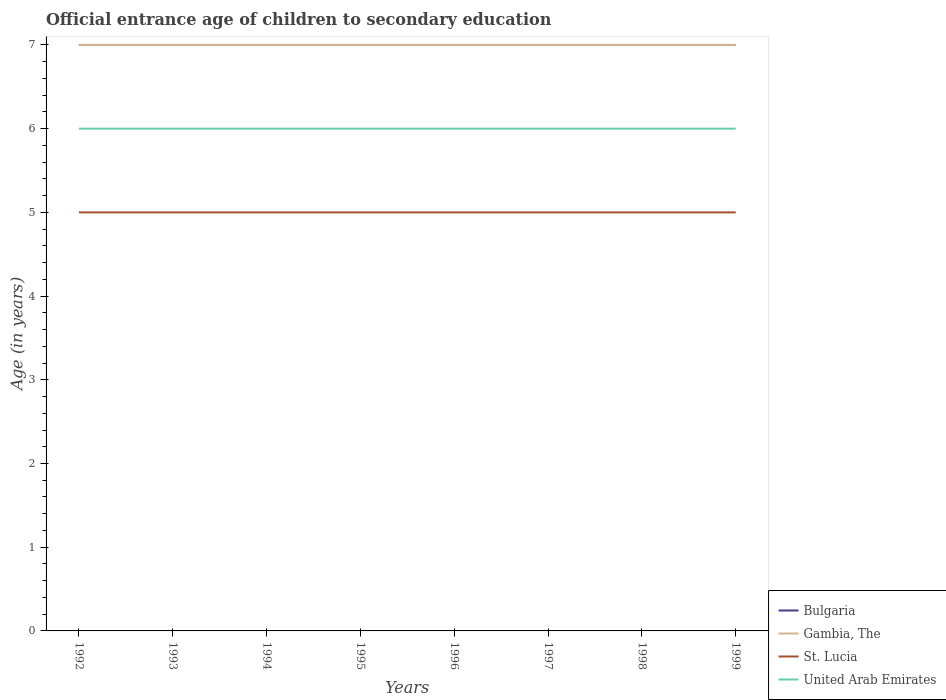Across all years, what is the maximum secondary school starting age of children in Bulgaria?
Ensure brevity in your answer.  7. What is the total secondary school starting age of children in United Arab Emirates in the graph?
Give a very brief answer. 0. What is the difference between the highest and the lowest secondary school starting age of children in United Arab Emirates?
Give a very brief answer. 0. How many lines are there?
Keep it short and to the point. 4. What is the difference between two consecutive major ticks on the Y-axis?
Offer a very short reply. 1. Are the values on the major ticks of Y-axis written in scientific E-notation?
Your answer should be compact. No. How many legend labels are there?
Provide a succinct answer. 4. How are the legend labels stacked?
Ensure brevity in your answer.  Vertical. What is the title of the graph?
Your answer should be compact. Official entrance age of children to secondary education. What is the label or title of the X-axis?
Your answer should be very brief. Years. What is the label or title of the Y-axis?
Offer a very short reply. Age (in years). What is the Age (in years) in Bulgaria in 1993?
Your answer should be very brief. 7. What is the Age (in years) in Gambia, The in 1993?
Your answer should be compact. 7. What is the Age (in years) of United Arab Emirates in 1993?
Offer a terse response. 6. What is the Age (in years) in Bulgaria in 1994?
Give a very brief answer. 7. What is the Age (in years) of Gambia, The in 1994?
Give a very brief answer. 7. What is the Age (in years) in United Arab Emirates in 1994?
Offer a terse response. 6. What is the Age (in years) in Gambia, The in 1995?
Offer a terse response. 7. What is the Age (in years) of St. Lucia in 1995?
Make the answer very short. 5. What is the Age (in years) in United Arab Emirates in 1995?
Provide a succinct answer. 6. What is the Age (in years) of Bulgaria in 1996?
Keep it short and to the point. 7. What is the Age (in years) of St. Lucia in 1996?
Give a very brief answer. 5. What is the Age (in years) in Gambia, The in 1997?
Offer a very short reply. 7. What is the Age (in years) of Bulgaria in 1998?
Keep it short and to the point. 7. What is the Age (in years) of Gambia, The in 1998?
Make the answer very short. 7. What is the Age (in years) of United Arab Emirates in 1998?
Ensure brevity in your answer.  6. What is the Age (in years) of St. Lucia in 1999?
Make the answer very short. 5. Across all years, what is the maximum Age (in years) in Gambia, The?
Your response must be concise. 7. Across all years, what is the maximum Age (in years) of United Arab Emirates?
Your response must be concise. 6. Across all years, what is the minimum Age (in years) of Bulgaria?
Keep it short and to the point. 7. Across all years, what is the minimum Age (in years) in Gambia, The?
Provide a succinct answer. 7. Across all years, what is the minimum Age (in years) of United Arab Emirates?
Your answer should be compact. 6. What is the total Age (in years) of St. Lucia in the graph?
Ensure brevity in your answer.  40. What is the difference between the Age (in years) in Bulgaria in 1992 and that in 1993?
Make the answer very short. 0. What is the difference between the Age (in years) in St. Lucia in 1992 and that in 1993?
Your answer should be very brief. 0. What is the difference between the Age (in years) of Bulgaria in 1992 and that in 1994?
Offer a very short reply. 0. What is the difference between the Age (in years) of Gambia, The in 1992 and that in 1994?
Your response must be concise. 0. What is the difference between the Age (in years) in St. Lucia in 1992 and that in 1994?
Your answer should be compact. 0. What is the difference between the Age (in years) in Bulgaria in 1992 and that in 1995?
Offer a terse response. 0. What is the difference between the Age (in years) of Gambia, The in 1992 and that in 1995?
Your answer should be very brief. 0. What is the difference between the Age (in years) in United Arab Emirates in 1992 and that in 1996?
Offer a very short reply. 0. What is the difference between the Age (in years) in Gambia, The in 1992 and that in 1997?
Provide a succinct answer. 0. What is the difference between the Age (in years) of St. Lucia in 1992 and that in 1997?
Offer a terse response. 0. What is the difference between the Age (in years) of United Arab Emirates in 1992 and that in 1997?
Ensure brevity in your answer.  0. What is the difference between the Age (in years) of Bulgaria in 1992 and that in 1998?
Make the answer very short. 0. What is the difference between the Age (in years) of Gambia, The in 1992 and that in 1998?
Your answer should be compact. 0. What is the difference between the Age (in years) of St. Lucia in 1992 and that in 1998?
Ensure brevity in your answer.  0. What is the difference between the Age (in years) of United Arab Emirates in 1992 and that in 1998?
Give a very brief answer. 0. What is the difference between the Age (in years) of Bulgaria in 1992 and that in 1999?
Your answer should be very brief. 0. What is the difference between the Age (in years) of Gambia, The in 1992 and that in 1999?
Make the answer very short. 0. What is the difference between the Age (in years) in St. Lucia in 1992 and that in 1999?
Offer a terse response. 0. What is the difference between the Age (in years) in Bulgaria in 1993 and that in 1994?
Provide a short and direct response. 0. What is the difference between the Age (in years) of St. Lucia in 1993 and that in 1994?
Give a very brief answer. 0. What is the difference between the Age (in years) of St. Lucia in 1993 and that in 1995?
Provide a succinct answer. 0. What is the difference between the Age (in years) of United Arab Emirates in 1993 and that in 1995?
Keep it short and to the point. 0. What is the difference between the Age (in years) of Bulgaria in 1993 and that in 1996?
Provide a succinct answer. 0. What is the difference between the Age (in years) of Gambia, The in 1993 and that in 1996?
Your response must be concise. 0. What is the difference between the Age (in years) of St. Lucia in 1993 and that in 1996?
Give a very brief answer. 0. What is the difference between the Age (in years) in Bulgaria in 1993 and that in 1997?
Provide a succinct answer. 0. What is the difference between the Age (in years) of Gambia, The in 1993 and that in 1997?
Give a very brief answer. 0. What is the difference between the Age (in years) of Gambia, The in 1993 and that in 1998?
Offer a very short reply. 0. What is the difference between the Age (in years) of St. Lucia in 1993 and that in 1998?
Provide a short and direct response. 0. What is the difference between the Age (in years) of Bulgaria in 1993 and that in 1999?
Provide a short and direct response. 0. What is the difference between the Age (in years) in Gambia, The in 1993 and that in 1999?
Ensure brevity in your answer.  0. What is the difference between the Age (in years) in St. Lucia in 1993 and that in 1999?
Give a very brief answer. 0. What is the difference between the Age (in years) of United Arab Emirates in 1993 and that in 1999?
Provide a short and direct response. 0. What is the difference between the Age (in years) of Bulgaria in 1994 and that in 1995?
Offer a very short reply. 0. What is the difference between the Age (in years) in St. Lucia in 1994 and that in 1995?
Provide a short and direct response. 0. What is the difference between the Age (in years) in Bulgaria in 1994 and that in 1996?
Your answer should be very brief. 0. What is the difference between the Age (in years) in Gambia, The in 1994 and that in 1996?
Ensure brevity in your answer.  0. What is the difference between the Age (in years) in Bulgaria in 1994 and that in 1997?
Provide a succinct answer. 0. What is the difference between the Age (in years) of Gambia, The in 1994 and that in 1997?
Make the answer very short. 0. What is the difference between the Age (in years) of St. Lucia in 1994 and that in 1997?
Provide a short and direct response. 0. What is the difference between the Age (in years) of Gambia, The in 1994 and that in 1998?
Offer a terse response. 0. What is the difference between the Age (in years) of St. Lucia in 1994 and that in 1998?
Make the answer very short. 0. What is the difference between the Age (in years) in United Arab Emirates in 1994 and that in 1998?
Your answer should be very brief. 0. What is the difference between the Age (in years) of Gambia, The in 1994 and that in 1999?
Provide a succinct answer. 0. What is the difference between the Age (in years) in St. Lucia in 1994 and that in 1999?
Keep it short and to the point. 0. What is the difference between the Age (in years) of United Arab Emirates in 1994 and that in 1999?
Offer a very short reply. 0. What is the difference between the Age (in years) in Bulgaria in 1995 and that in 1996?
Make the answer very short. 0. What is the difference between the Age (in years) of Bulgaria in 1995 and that in 1997?
Provide a succinct answer. 0. What is the difference between the Age (in years) of Gambia, The in 1995 and that in 1997?
Your answer should be very brief. 0. What is the difference between the Age (in years) of United Arab Emirates in 1995 and that in 1997?
Make the answer very short. 0. What is the difference between the Age (in years) in Bulgaria in 1995 and that in 1998?
Offer a terse response. 0. What is the difference between the Age (in years) in Gambia, The in 1995 and that in 1998?
Give a very brief answer. 0. What is the difference between the Age (in years) in United Arab Emirates in 1995 and that in 1998?
Provide a short and direct response. 0. What is the difference between the Age (in years) of Bulgaria in 1995 and that in 1999?
Offer a terse response. 0. What is the difference between the Age (in years) in United Arab Emirates in 1995 and that in 1999?
Your answer should be compact. 0. What is the difference between the Age (in years) in Bulgaria in 1996 and that in 1997?
Your answer should be very brief. 0. What is the difference between the Age (in years) in St. Lucia in 1996 and that in 1997?
Your response must be concise. 0. What is the difference between the Age (in years) in United Arab Emirates in 1996 and that in 1997?
Provide a succinct answer. 0. What is the difference between the Age (in years) in Gambia, The in 1996 and that in 1998?
Provide a short and direct response. 0. What is the difference between the Age (in years) in St. Lucia in 1996 and that in 1998?
Offer a terse response. 0. What is the difference between the Age (in years) of Gambia, The in 1996 and that in 1999?
Your answer should be very brief. 0. What is the difference between the Age (in years) in St. Lucia in 1996 and that in 1999?
Ensure brevity in your answer.  0. What is the difference between the Age (in years) in United Arab Emirates in 1996 and that in 1999?
Keep it short and to the point. 0. What is the difference between the Age (in years) in Bulgaria in 1997 and that in 1998?
Give a very brief answer. 0. What is the difference between the Age (in years) of St. Lucia in 1997 and that in 1998?
Your answer should be compact. 0. What is the difference between the Age (in years) of St. Lucia in 1997 and that in 1999?
Your answer should be compact. 0. What is the difference between the Age (in years) in United Arab Emirates in 1997 and that in 1999?
Provide a short and direct response. 0. What is the difference between the Age (in years) of Gambia, The in 1998 and that in 1999?
Your answer should be very brief. 0. What is the difference between the Age (in years) in Bulgaria in 1992 and the Age (in years) in Gambia, The in 1993?
Your answer should be compact. 0. What is the difference between the Age (in years) of Bulgaria in 1992 and the Age (in years) of United Arab Emirates in 1993?
Your answer should be very brief. 1. What is the difference between the Age (in years) of Gambia, The in 1992 and the Age (in years) of United Arab Emirates in 1993?
Give a very brief answer. 1. What is the difference between the Age (in years) of St. Lucia in 1992 and the Age (in years) of United Arab Emirates in 1993?
Make the answer very short. -1. What is the difference between the Age (in years) of Bulgaria in 1992 and the Age (in years) of United Arab Emirates in 1994?
Provide a succinct answer. 1. What is the difference between the Age (in years) in Gambia, The in 1992 and the Age (in years) in United Arab Emirates in 1995?
Offer a very short reply. 1. What is the difference between the Age (in years) in Bulgaria in 1992 and the Age (in years) in Gambia, The in 1996?
Give a very brief answer. 0. What is the difference between the Age (in years) in Bulgaria in 1992 and the Age (in years) in St. Lucia in 1996?
Ensure brevity in your answer.  2. What is the difference between the Age (in years) in Bulgaria in 1992 and the Age (in years) in United Arab Emirates in 1996?
Provide a short and direct response. 1. What is the difference between the Age (in years) of Gambia, The in 1992 and the Age (in years) of St. Lucia in 1996?
Keep it short and to the point. 2. What is the difference between the Age (in years) of Gambia, The in 1992 and the Age (in years) of United Arab Emirates in 1996?
Provide a succinct answer. 1. What is the difference between the Age (in years) of St. Lucia in 1992 and the Age (in years) of United Arab Emirates in 1996?
Keep it short and to the point. -1. What is the difference between the Age (in years) in Bulgaria in 1992 and the Age (in years) in St. Lucia in 1997?
Make the answer very short. 2. What is the difference between the Age (in years) in Bulgaria in 1992 and the Age (in years) in United Arab Emirates in 1997?
Offer a terse response. 1. What is the difference between the Age (in years) of St. Lucia in 1992 and the Age (in years) of United Arab Emirates in 1997?
Provide a short and direct response. -1. What is the difference between the Age (in years) of Bulgaria in 1992 and the Age (in years) of Gambia, The in 1998?
Offer a terse response. 0. What is the difference between the Age (in years) of Bulgaria in 1992 and the Age (in years) of St. Lucia in 1998?
Give a very brief answer. 2. What is the difference between the Age (in years) in Bulgaria in 1992 and the Age (in years) in United Arab Emirates in 1998?
Offer a terse response. 1. What is the difference between the Age (in years) of Gambia, The in 1992 and the Age (in years) of St. Lucia in 1998?
Offer a terse response. 2. What is the difference between the Age (in years) of Gambia, The in 1992 and the Age (in years) of United Arab Emirates in 1998?
Give a very brief answer. 1. What is the difference between the Age (in years) in Bulgaria in 1992 and the Age (in years) in St. Lucia in 1999?
Offer a very short reply. 2. What is the difference between the Age (in years) in Bulgaria in 1992 and the Age (in years) in United Arab Emirates in 1999?
Offer a terse response. 1. What is the difference between the Age (in years) of Bulgaria in 1993 and the Age (in years) of Gambia, The in 1994?
Provide a short and direct response. 0. What is the difference between the Age (in years) of Bulgaria in 1993 and the Age (in years) of United Arab Emirates in 1994?
Provide a succinct answer. 1. What is the difference between the Age (in years) of Gambia, The in 1993 and the Age (in years) of United Arab Emirates in 1994?
Offer a very short reply. 1. What is the difference between the Age (in years) of St. Lucia in 1993 and the Age (in years) of United Arab Emirates in 1994?
Ensure brevity in your answer.  -1. What is the difference between the Age (in years) of Bulgaria in 1993 and the Age (in years) of St. Lucia in 1995?
Your answer should be very brief. 2. What is the difference between the Age (in years) of Bulgaria in 1993 and the Age (in years) of United Arab Emirates in 1995?
Keep it short and to the point. 1. What is the difference between the Age (in years) of Gambia, The in 1993 and the Age (in years) of St. Lucia in 1995?
Ensure brevity in your answer.  2. What is the difference between the Age (in years) of Bulgaria in 1993 and the Age (in years) of Gambia, The in 1996?
Provide a short and direct response. 0. What is the difference between the Age (in years) in Bulgaria in 1993 and the Age (in years) in St. Lucia in 1996?
Ensure brevity in your answer.  2. What is the difference between the Age (in years) of Bulgaria in 1993 and the Age (in years) of United Arab Emirates in 1996?
Your answer should be very brief. 1. What is the difference between the Age (in years) in St. Lucia in 1993 and the Age (in years) in United Arab Emirates in 1996?
Keep it short and to the point. -1. What is the difference between the Age (in years) in Bulgaria in 1993 and the Age (in years) in St. Lucia in 1997?
Provide a succinct answer. 2. What is the difference between the Age (in years) of Gambia, The in 1993 and the Age (in years) of St. Lucia in 1997?
Your answer should be compact. 2. What is the difference between the Age (in years) of Gambia, The in 1993 and the Age (in years) of St. Lucia in 1998?
Give a very brief answer. 2. What is the difference between the Age (in years) of Gambia, The in 1993 and the Age (in years) of United Arab Emirates in 1998?
Offer a terse response. 1. What is the difference between the Age (in years) of St. Lucia in 1993 and the Age (in years) of United Arab Emirates in 1998?
Give a very brief answer. -1. What is the difference between the Age (in years) of Bulgaria in 1993 and the Age (in years) of Gambia, The in 1999?
Provide a succinct answer. 0. What is the difference between the Age (in years) in Bulgaria in 1993 and the Age (in years) in St. Lucia in 1999?
Ensure brevity in your answer.  2. What is the difference between the Age (in years) in Gambia, The in 1993 and the Age (in years) in United Arab Emirates in 1999?
Make the answer very short. 1. What is the difference between the Age (in years) of St. Lucia in 1993 and the Age (in years) of United Arab Emirates in 1999?
Keep it short and to the point. -1. What is the difference between the Age (in years) in Bulgaria in 1994 and the Age (in years) in Gambia, The in 1995?
Give a very brief answer. 0. What is the difference between the Age (in years) in Bulgaria in 1994 and the Age (in years) in St. Lucia in 1995?
Offer a terse response. 2. What is the difference between the Age (in years) in St. Lucia in 1994 and the Age (in years) in United Arab Emirates in 1995?
Keep it short and to the point. -1. What is the difference between the Age (in years) in Bulgaria in 1994 and the Age (in years) in Gambia, The in 1996?
Your answer should be compact. 0. What is the difference between the Age (in years) in Bulgaria in 1994 and the Age (in years) in St. Lucia in 1996?
Offer a terse response. 2. What is the difference between the Age (in years) of Bulgaria in 1994 and the Age (in years) of United Arab Emirates in 1996?
Offer a terse response. 1. What is the difference between the Age (in years) of Gambia, The in 1994 and the Age (in years) of St. Lucia in 1996?
Provide a succinct answer. 2. What is the difference between the Age (in years) of St. Lucia in 1994 and the Age (in years) of United Arab Emirates in 1996?
Provide a succinct answer. -1. What is the difference between the Age (in years) of Bulgaria in 1994 and the Age (in years) of Gambia, The in 1997?
Offer a terse response. 0. What is the difference between the Age (in years) in Bulgaria in 1994 and the Age (in years) in St. Lucia in 1997?
Offer a very short reply. 2. What is the difference between the Age (in years) in Bulgaria in 1994 and the Age (in years) in United Arab Emirates in 1998?
Give a very brief answer. 1. What is the difference between the Age (in years) in Gambia, The in 1994 and the Age (in years) in St. Lucia in 1998?
Provide a short and direct response. 2. What is the difference between the Age (in years) in Gambia, The in 1994 and the Age (in years) in United Arab Emirates in 1998?
Your answer should be compact. 1. What is the difference between the Age (in years) in St. Lucia in 1994 and the Age (in years) in United Arab Emirates in 1998?
Your answer should be very brief. -1. What is the difference between the Age (in years) of Gambia, The in 1994 and the Age (in years) of St. Lucia in 1999?
Keep it short and to the point. 2. What is the difference between the Age (in years) of Bulgaria in 1995 and the Age (in years) of St. Lucia in 1996?
Provide a succinct answer. 2. What is the difference between the Age (in years) in St. Lucia in 1995 and the Age (in years) in United Arab Emirates in 1997?
Provide a short and direct response. -1. What is the difference between the Age (in years) in Bulgaria in 1995 and the Age (in years) in St. Lucia in 1998?
Offer a terse response. 2. What is the difference between the Age (in years) of Gambia, The in 1995 and the Age (in years) of United Arab Emirates in 1998?
Provide a succinct answer. 1. What is the difference between the Age (in years) in St. Lucia in 1995 and the Age (in years) in United Arab Emirates in 1998?
Give a very brief answer. -1. What is the difference between the Age (in years) in Bulgaria in 1995 and the Age (in years) in United Arab Emirates in 1999?
Make the answer very short. 1. What is the difference between the Age (in years) in Gambia, The in 1995 and the Age (in years) in St. Lucia in 1999?
Provide a succinct answer. 2. What is the difference between the Age (in years) in Bulgaria in 1996 and the Age (in years) in Gambia, The in 1997?
Offer a terse response. 0. What is the difference between the Age (in years) in Bulgaria in 1996 and the Age (in years) in United Arab Emirates in 1997?
Provide a succinct answer. 1. What is the difference between the Age (in years) in Gambia, The in 1996 and the Age (in years) in St. Lucia in 1997?
Keep it short and to the point. 2. What is the difference between the Age (in years) of Gambia, The in 1996 and the Age (in years) of St. Lucia in 1998?
Ensure brevity in your answer.  2. What is the difference between the Age (in years) of Gambia, The in 1996 and the Age (in years) of United Arab Emirates in 1998?
Offer a terse response. 1. What is the difference between the Age (in years) of St. Lucia in 1996 and the Age (in years) of United Arab Emirates in 1998?
Make the answer very short. -1. What is the difference between the Age (in years) of Bulgaria in 1996 and the Age (in years) of Gambia, The in 1999?
Ensure brevity in your answer.  0. What is the difference between the Age (in years) of Bulgaria in 1997 and the Age (in years) of Gambia, The in 1998?
Offer a terse response. 0. What is the difference between the Age (in years) in Bulgaria in 1997 and the Age (in years) in St. Lucia in 1998?
Your answer should be very brief. 2. What is the difference between the Age (in years) in St. Lucia in 1997 and the Age (in years) in United Arab Emirates in 1999?
Ensure brevity in your answer.  -1. What is the difference between the Age (in years) of Bulgaria in 1998 and the Age (in years) of Gambia, The in 1999?
Offer a very short reply. 0. What is the difference between the Age (in years) in St. Lucia in 1998 and the Age (in years) in United Arab Emirates in 1999?
Offer a terse response. -1. What is the average Age (in years) in United Arab Emirates per year?
Provide a short and direct response. 6. In the year 1992, what is the difference between the Age (in years) in Bulgaria and Age (in years) in Gambia, The?
Provide a succinct answer. 0. In the year 1992, what is the difference between the Age (in years) of Bulgaria and Age (in years) of St. Lucia?
Make the answer very short. 2. In the year 1992, what is the difference between the Age (in years) in Gambia, The and Age (in years) in St. Lucia?
Make the answer very short. 2. In the year 1992, what is the difference between the Age (in years) of St. Lucia and Age (in years) of United Arab Emirates?
Make the answer very short. -1. In the year 1993, what is the difference between the Age (in years) of Bulgaria and Age (in years) of St. Lucia?
Provide a succinct answer. 2. In the year 1993, what is the difference between the Age (in years) in Gambia, The and Age (in years) in United Arab Emirates?
Your answer should be compact. 1. In the year 1993, what is the difference between the Age (in years) in St. Lucia and Age (in years) in United Arab Emirates?
Provide a succinct answer. -1. In the year 1994, what is the difference between the Age (in years) in Bulgaria and Age (in years) in Gambia, The?
Your response must be concise. 0. In the year 1994, what is the difference between the Age (in years) of Bulgaria and Age (in years) of United Arab Emirates?
Your answer should be compact. 1. In the year 1994, what is the difference between the Age (in years) of Gambia, The and Age (in years) of United Arab Emirates?
Offer a terse response. 1. In the year 1995, what is the difference between the Age (in years) in Bulgaria and Age (in years) in Gambia, The?
Give a very brief answer. 0. In the year 1995, what is the difference between the Age (in years) in Bulgaria and Age (in years) in St. Lucia?
Offer a very short reply. 2. In the year 1995, what is the difference between the Age (in years) in Bulgaria and Age (in years) in United Arab Emirates?
Make the answer very short. 1. In the year 1995, what is the difference between the Age (in years) in Gambia, The and Age (in years) in St. Lucia?
Make the answer very short. 2. In the year 1995, what is the difference between the Age (in years) of St. Lucia and Age (in years) of United Arab Emirates?
Make the answer very short. -1. In the year 1996, what is the difference between the Age (in years) in Bulgaria and Age (in years) in Gambia, The?
Keep it short and to the point. 0. In the year 1996, what is the difference between the Age (in years) of Bulgaria and Age (in years) of United Arab Emirates?
Offer a terse response. 1. In the year 1996, what is the difference between the Age (in years) of Gambia, The and Age (in years) of St. Lucia?
Your answer should be compact. 2. In the year 1996, what is the difference between the Age (in years) of Gambia, The and Age (in years) of United Arab Emirates?
Ensure brevity in your answer.  1. In the year 1997, what is the difference between the Age (in years) of Bulgaria and Age (in years) of Gambia, The?
Your response must be concise. 0. In the year 1997, what is the difference between the Age (in years) in Bulgaria and Age (in years) in St. Lucia?
Offer a very short reply. 2. In the year 1997, what is the difference between the Age (in years) in Gambia, The and Age (in years) in United Arab Emirates?
Your answer should be very brief. 1. In the year 1998, what is the difference between the Age (in years) in Bulgaria and Age (in years) in Gambia, The?
Offer a very short reply. 0. In the year 1998, what is the difference between the Age (in years) of Bulgaria and Age (in years) of St. Lucia?
Provide a succinct answer. 2. In the year 1998, what is the difference between the Age (in years) in Gambia, The and Age (in years) in St. Lucia?
Offer a very short reply. 2. In the year 1998, what is the difference between the Age (in years) of St. Lucia and Age (in years) of United Arab Emirates?
Offer a very short reply. -1. In the year 1999, what is the difference between the Age (in years) in Bulgaria and Age (in years) in Gambia, The?
Provide a short and direct response. 0. In the year 1999, what is the difference between the Age (in years) of Gambia, The and Age (in years) of St. Lucia?
Give a very brief answer. 2. In the year 1999, what is the difference between the Age (in years) in St. Lucia and Age (in years) in United Arab Emirates?
Your response must be concise. -1. What is the ratio of the Age (in years) of Bulgaria in 1992 to that in 1993?
Keep it short and to the point. 1. What is the ratio of the Age (in years) of Gambia, The in 1992 to that in 1993?
Provide a succinct answer. 1. What is the ratio of the Age (in years) in United Arab Emirates in 1992 to that in 1993?
Offer a terse response. 1. What is the ratio of the Age (in years) in Bulgaria in 1992 to that in 1994?
Your answer should be very brief. 1. What is the ratio of the Age (in years) in Gambia, The in 1992 to that in 1995?
Your answer should be compact. 1. What is the ratio of the Age (in years) in St. Lucia in 1992 to that in 1995?
Make the answer very short. 1. What is the ratio of the Age (in years) in Bulgaria in 1992 to that in 1996?
Ensure brevity in your answer.  1. What is the ratio of the Age (in years) of Bulgaria in 1992 to that in 1997?
Give a very brief answer. 1. What is the ratio of the Age (in years) of St. Lucia in 1992 to that in 1997?
Give a very brief answer. 1. What is the ratio of the Age (in years) of United Arab Emirates in 1992 to that in 1997?
Your answer should be very brief. 1. What is the ratio of the Age (in years) in St. Lucia in 1992 to that in 1998?
Your answer should be very brief. 1. What is the ratio of the Age (in years) in United Arab Emirates in 1992 to that in 1998?
Give a very brief answer. 1. What is the ratio of the Age (in years) of Bulgaria in 1992 to that in 1999?
Provide a succinct answer. 1. What is the ratio of the Age (in years) of St. Lucia in 1992 to that in 1999?
Your answer should be very brief. 1. What is the ratio of the Age (in years) in United Arab Emirates in 1992 to that in 1999?
Offer a terse response. 1. What is the ratio of the Age (in years) in Bulgaria in 1993 to that in 1994?
Offer a very short reply. 1. What is the ratio of the Age (in years) in Gambia, The in 1993 to that in 1994?
Keep it short and to the point. 1. What is the ratio of the Age (in years) in United Arab Emirates in 1993 to that in 1994?
Offer a very short reply. 1. What is the ratio of the Age (in years) in Gambia, The in 1993 to that in 1995?
Give a very brief answer. 1. What is the ratio of the Age (in years) in United Arab Emirates in 1993 to that in 1996?
Ensure brevity in your answer.  1. What is the ratio of the Age (in years) in Bulgaria in 1993 to that in 1997?
Ensure brevity in your answer.  1. What is the ratio of the Age (in years) in Gambia, The in 1993 to that in 1997?
Provide a short and direct response. 1. What is the ratio of the Age (in years) of St. Lucia in 1993 to that in 1998?
Provide a short and direct response. 1. What is the ratio of the Age (in years) in Bulgaria in 1993 to that in 1999?
Your answer should be very brief. 1. What is the ratio of the Age (in years) in Gambia, The in 1993 to that in 1999?
Your answer should be very brief. 1. What is the ratio of the Age (in years) in St. Lucia in 1993 to that in 1999?
Your answer should be very brief. 1. What is the ratio of the Age (in years) in United Arab Emirates in 1993 to that in 1999?
Ensure brevity in your answer.  1. What is the ratio of the Age (in years) in Gambia, The in 1994 to that in 1995?
Keep it short and to the point. 1. What is the ratio of the Age (in years) of Bulgaria in 1994 to that in 1996?
Your response must be concise. 1. What is the ratio of the Age (in years) of Gambia, The in 1994 to that in 1996?
Give a very brief answer. 1. What is the ratio of the Age (in years) of United Arab Emirates in 1994 to that in 1996?
Your answer should be very brief. 1. What is the ratio of the Age (in years) of Bulgaria in 1994 to that in 1997?
Your response must be concise. 1. What is the ratio of the Age (in years) of Gambia, The in 1994 to that in 1997?
Offer a terse response. 1. What is the ratio of the Age (in years) in St. Lucia in 1994 to that in 1998?
Your answer should be very brief. 1. What is the ratio of the Age (in years) in St. Lucia in 1994 to that in 1999?
Offer a very short reply. 1. What is the ratio of the Age (in years) in United Arab Emirates in 1994 to that in 1999?
Offer a terse response. 1. What is the ratio of the Age (in years) in Bulgaria in 1995 to that in 1996?
Ensure brevity in your answer.  1. What is the ratio of the Age (in years) of Gambia, The in 1995 to that in 1996?
Give a very brief answer. 1. What is the ratio of the Age (in years) in United Arab Emirates in 1995 to that in 1996?
Keep it short and to the point. 1. What is the ratio of the Age (in years) in Gambia, The in 1995 to that in 1997?
Offer a very short reply. 1. What is the ratio of the Age (in years) in United Arab Emirates in 1995 to that in 1997?
Offer a very short reply. 1. What is the ratio of the Age (in years) of Bulgaria in 1995 to that in 1998?
Offer a very short reply. 1. What is the ratio of the Age (in years) of United Arab Emirates in 1995 to that in 1998?
Keep it short and to the point. 1. What is the ratio of the Age (in years) of United Arab Emirates in 1995 to that in 1999?
Ensure brevity in your answer.  1. What is the ratio of the Age (in years) in Gambia, The in 1996 to that in 1997?
Your answer should be compact. 1. What is the ratio of the Age (in years) in St. Lucia in 1996 to that in 1997?
Make the answer very short. 1. What is the ratio of the Age (in years) in United Arab Emirates in 1996 to that in 1997?
Give a very brief answer. 1. What is the ratio of the Age (in years) in Bulgaria in 1996 to that in 1998?
Ensure brevity in your answer.  1. What is the ratio of the Age (in years) in Gambia, The in 1996 to that in 1998?
Make the answer very short. 1. What is the ratio of the Age (in years) of Bulgaria in 1996 to that in 1999?
Ensure brevity in your answer.  1. What is the ratio of the Age (in years) of Gambia, The in 1996 to that in 1999?
Keep it short and to the point. 1. What is the ratio of the Age (in years) in St. Lucia in 1996 to that in 1999?
Your response must be concise. 1. What is the ratio of the Age (in years) in United Arab Emirates in 1996 to that in 1999?
Ensure brevity in your answer.  1. What is the ratio of the Age (in years) in Bulgaria in 1997 to that in 1999?
Offer a terse response. 1. What is the ratio of the Age (in years) of United Arab Emirates in 1997 to that in 1999?
Offer a very short reply. 1. What is the ratio of the Age (in years) of Bulgaria in 1998 to that in 1999?
Provide a succinct answer. 1. What is the ratio of the Age (in years) in United Arab Emirates in 1998 to that in 1999?
Offer a very short reply. 1. What is the difference between the highest and the lowest Age (in years) of Bulgaria?
Keep it short and to the point. 0. What is the difference between the highest and the lowest Age (in years) of Gambia, The?
Give a very brief answer. 0. What is the difference between the highest and the lowest Age (in years) in St. Lucia?
Offer a terse response. 0. What is the difference between the highest and the lowest Age (in years) of United Arab Emirates?
Your answer should be very brief. 0. 